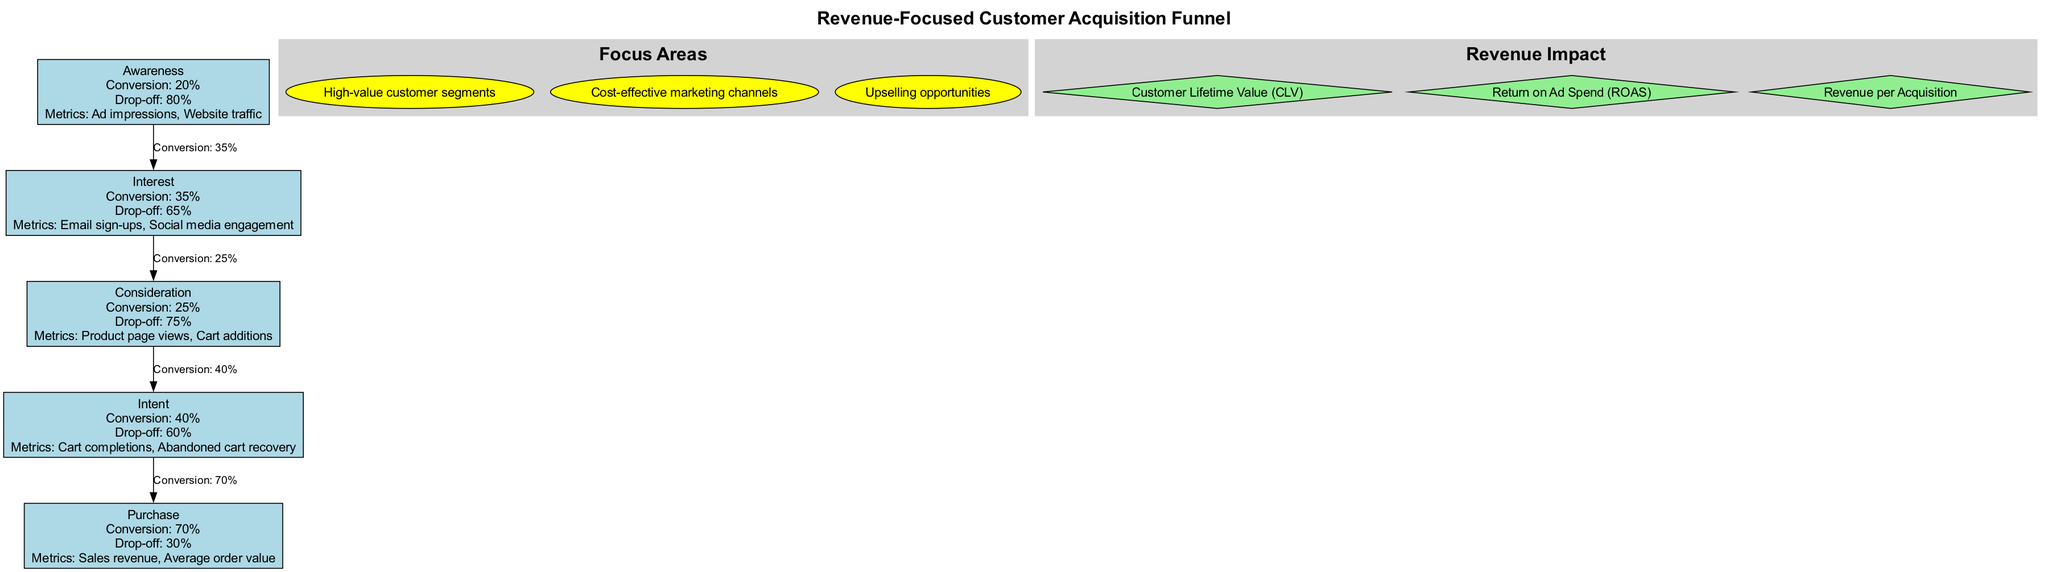What is the conversion rate at the Consideration stage? The diagram indicates that the Consideration stage has a conversion rate of 25%. This information is directly stated in the node representing the Consideration stage.
Answer: 25% How many focus areas are highlighted in the diagram? The diagram features three focus areas, as shown in the cluster labeled "Focus Areas." Each focus area is represented as an individual node within that cluster.
Answer: 3 What is the drop-off percentage at the Intent stage? The Intent stage has a specified drop-off percentage of 60%. This figure is listed in the node corresponding to the Intent stage in the funnel.
Answer: 60% Which stage has the highest conversion rate? The Purchase stage has the highest conversion rate at 70%, as indicated prominently in its node. This is the highest figure when compared to all other stages of the funnel.
Answer: 70% What is one key metric in the Awareness stage? One key metric listed for the Awareness stage is "Ad impressions." This is part of the node detailing the metrics for that particular stage of the funnel.
Answer: Ad impressions What is the relationship between the Interest stage and the Purchase stage in terms of conversion? The Interest stage has a conversion rate of 35%, and the Purchase stage has a conversion rate of 70%. This shows that as potential customers move through the funnel from Interest to Purchase, the conversion rate significantly increases.
Answer: 35% to 70% What is the total drop-off percentage from Awareness to Purchase? To find the total drop-off percentage, we consider the drop-off percentages from each stage: 80% (Awareness) → 65% (Interest) → 75% (Consideration) → 60% (Intent) → 30% (Purchase). Tracking these stages shows that a large percentage of customers drop off at each point, cumulatively indicating retention challenges. The calculation is more complex, as it depends on the initial numbers, but sequentially they decline.
Answer: 30% What type of diagram is used to represent customer acquisition in the data provided? The diagram is structured as a "funnel," as indicated by its title and the arrangement of nodes in a descending formation, representing the customer acquisition process.
Answer: Funnel 